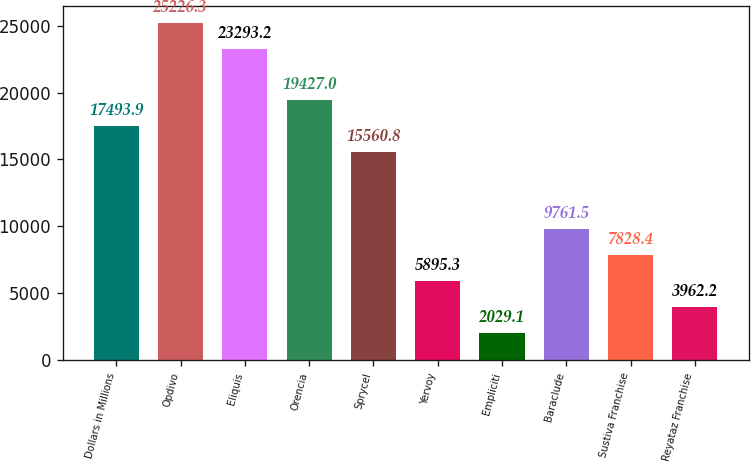Convert chart. <chart><loc_0><loc_0><loc_500><loc_500><bar_chart><fcel>Dollars in Millions<fcel>Opdivo<fcel>Eliquis<fcel>Orencia<fcel>Sprycel<fcel>Yervoy<fcel>Empliciti<fcel>Baraclude<fcel>Sustiva Franchise<fcel>Reyataz Franchise<nl><fcel>17493.9<fcel>25226.3<fcel>23293.2<fcel>19427<fcel>15560.8<fcel>5895.3<fcel>2029.1<fcel>9761.5<fcel>7828.4<fcel>3962.2<nl></chart> 